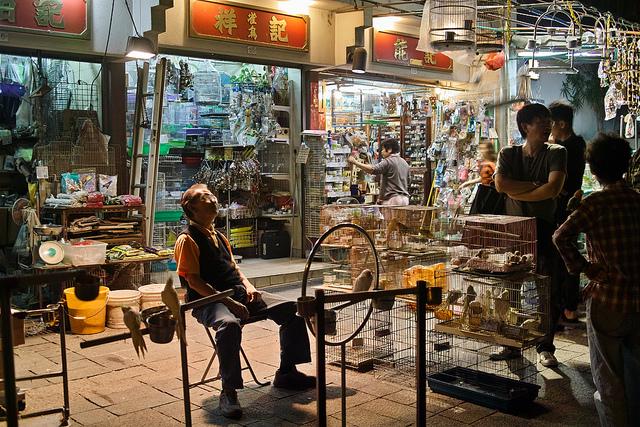What animal lives in the cages?
Answer briefly. Birds. What language are the signs written in?
Keep it brief. Chinese. What is the woman doing?
Be succinct. Standing. 